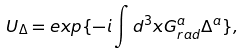Convert formula to latex. <formula><loc_0><loc_0><loc_500><loc_500>U _ { \Delta } = e x p \{ - i \int d ^ { 3 } x G _ { r a d } ^ { a } \Delta ^ { a } \} ,</formula> 